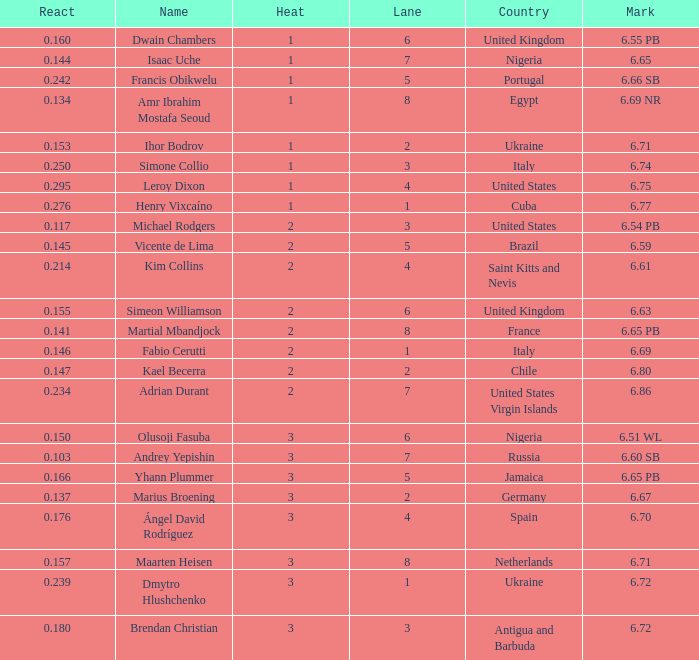Can you parse all the data within this table? {'header': ['React', 'Name', 'Heat', 'Lane', 'Country', 'Mark'], 'rows': [['0.160', 'Dwain Chambers', '1', '6', 'United Kingdom', '6.55 PB'], ['0.144', 'Isaac Uche', '1', '7', 'Nigeria', '6.65'], ['0.242', 'Francis Obikwelu', '1', '5', 'Portugal', '6.66 SB'], ['0.134', 'Amr Ibrahim Mostafa Seoud', '1', '8', 'Egypt', '6.69 NR'], ['0.153', 'Ihor Bodrov', '1', '2', 'Ukraine', '6.71'], ['0.250', 'Simone Collio', '1', '3', 'Italy', '6.74'], ['0.295', 'Leroy Dixon', '1', '4', 'United States', '6.75'], ['0.276', 'Henry Vixcaíno', '1', '1', 'Cuba', '6.77'], ['0.117', 'Michael Rodgers', '2', '3', 'United States', '6.54 PB'], ['0.145', 'Vicente de Lima', '2', '5', 'Brazil', '6.59'], ['0.214', 'Kim Collins', '2', '4', 'Saint Kitts and Nevis', '6.61'], ['0.155', 'Simeon Williamson', '2', '6', 'United Kingdom', '6.63'], ['0.141', 'Martial Mbandjock', '2', '8', 'France', '6.65 PB'], ['0.146', 'Fabio Cerutti', '2', '1', 'Italy', '6.69'], ['0.147', 'Kael Becerra', '2', '2', 'Chile', '6.80'], ['0.234', 'Adrian Durant', '2', '7', 'United States Virgin Islands', '6.86'], ['0.150', 'Olusoji Fasuba', '3', '6', 'Nigeria', '6.51 WL'], ['0.103', 'Andrey Yepishin', '3', '7', 'Russia', '6.60 SB'], ['0.166', 'Yhann Plummer', '3', '5', 'Jamaica', '6.65 PB'], ['0.137', 'Marius Broening', '3', '2', 'Germany', '6.67'], ['0.176', 'Ángel David Rodríguez', '3', '4', 'Spain', '6.70'], ['0.157', 'Maarten Heisen', '3', '8', 'Netherlands', '6.71'], ['0.239', 'Dmytro Hlushchenko', '3', '1', 'Ukraine', '6.72'], ['0.180', 'Brendan Christian', '3', '3', 'Antigua and Barbuda', '6.72']]} What is the lowest Lane, when Country is France, and when React is less than 0.14100000000000001? 8.0. 